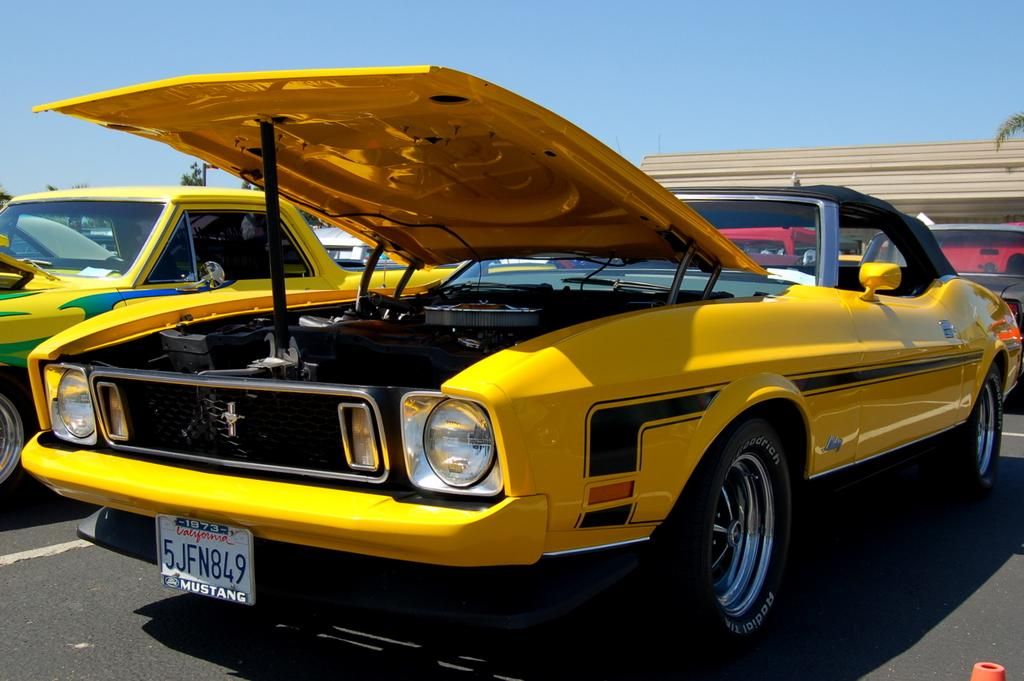<image>
Create a compact narrative representing the image presented. A classic yellow Mustang displayed with its hood open. 